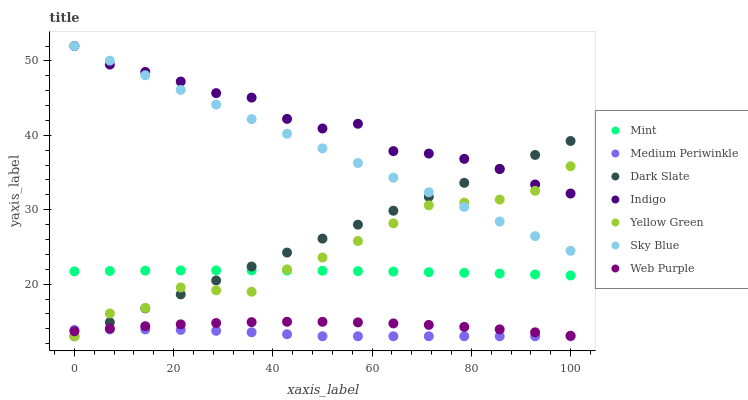Does Medium Periwinkle have the minimum area under the curve?
Answer yes or no. Yes. Does Indigo have the maximum area under the curve?
Answer yes or no. Yes. Does Yellow Green have the minimum area under the curve?
Answer yes or no. No. Does Yellow Green have the maximum area under the curve?
Answer yes or no. No. Is Dark Slate the smoothest?
Answer yes or no. Yes. Is Indigo the roughest?
Answer yes or no. Yes. Is Yellow Green the smoothest?
Answer yes or no. No. Is Yellow Green the roughest?
Answer yes or no. No. Does Yellow Green have the lowest value?
Answer yes or no. Yes. Does Web Purple have the lowest value?
Answer yes or no. No. Does Sky Blue have the highest value?
Answer yes or no. Yes. Does Yellow Green have the highest value?
Answer yes or no. No. Is Mint less than Sky Blue?
Answer yes or no. Yes. Is Sky Blue greater than Medium Periwinkle?
Answer yes or no. Yes. Does Yellow Green intersect Web Purple?
Answer yes or no. Yes. Is Yellow Green less than Web Purple?
Answer yes or no. No. Is Yellow Green greater than Web Purple?
Answer yes or no. No. Does Mint intersect Sky Blue?
Answer yes or no. No. 